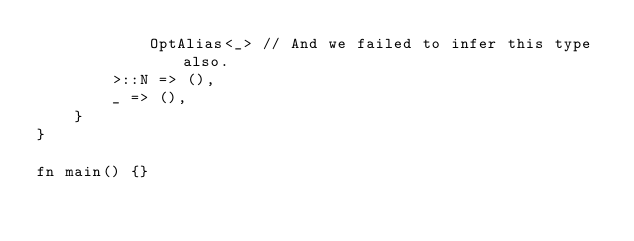Convert code to text. <code><loc_0><loc_0><loc_500><loc_500><_Rust_>            OptAlias<_> // And we failed to infer this type also.
        >::N => (),
        _ => (),
    }
}

fn main() {}
</code> 